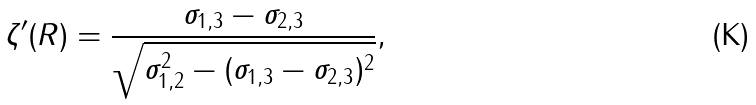<formula> <loc_0><loc_0><loc_500><loc_500>\zeta ^ { \prime } ( R ) = \frac { \sigma _ { 1 , 3 } - \sigma _ { 2 , 3 } } { \sqrt { \sigma _ { 1 , 2 } ^ { 2 } - ( \sigma _ { 1 , 3 } - \sigma _ { 2 , 3 } ) ^ { 2 } } } ,</formula> 